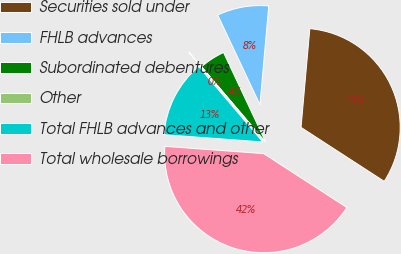Convert chart to OTSL. <chart><loc_0><loc_0><loc_500><loc_500><pie_chart><fcel>Securities sold under<fcel>FHLB advances<fcel>Subordinated debentures<fcel>Other<fcel>Total FHLB advances and other<fcel>Total wholesale borrowings<nl><fcel>32.74%<fcel>8.41%<fcel>4.21%<fcel>0.01%<fcel>12.61%<fcel>42.01%<nl></chart> 